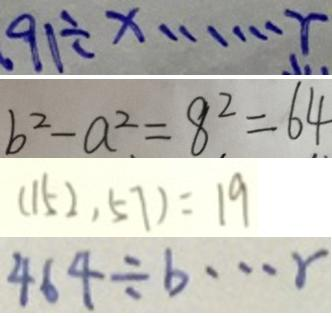Convert formula to latex. <formula><loc_0><loc_0><loc_500><loc_500>9 1 \div x \cdots r 
 b ^ { 2 } - a ^ { 2 } = 8 ^ { 2 } = 6 4 
 ( 1 5 2 , 5 7 ) = 1 9 
 4 6 4 \div b \cdots r</formula> 